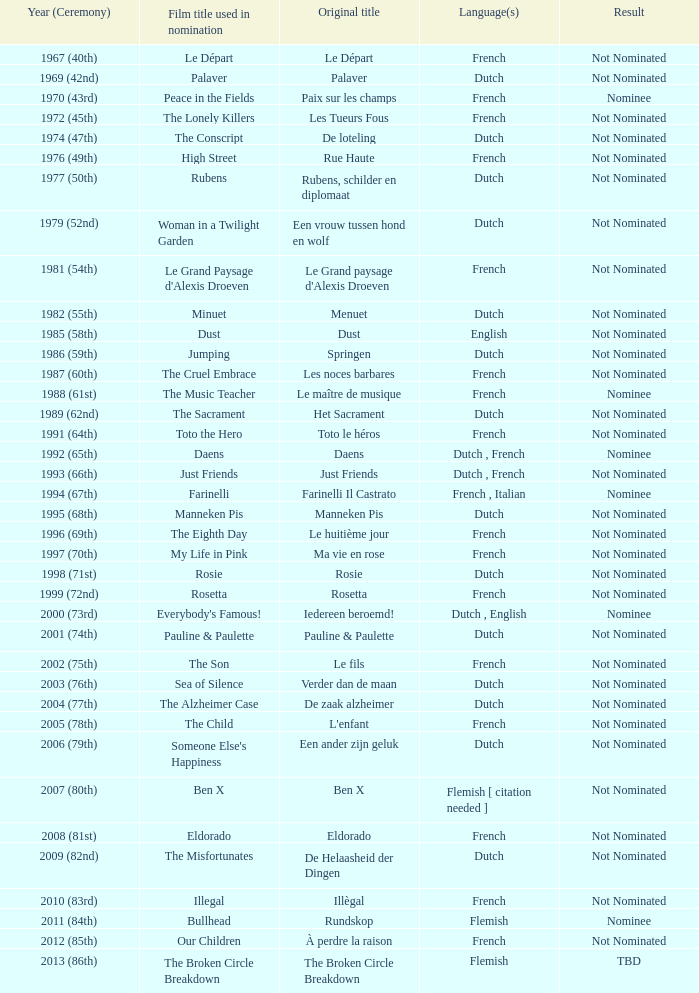What is the tongue spoken in the film rosie? Dutch. 